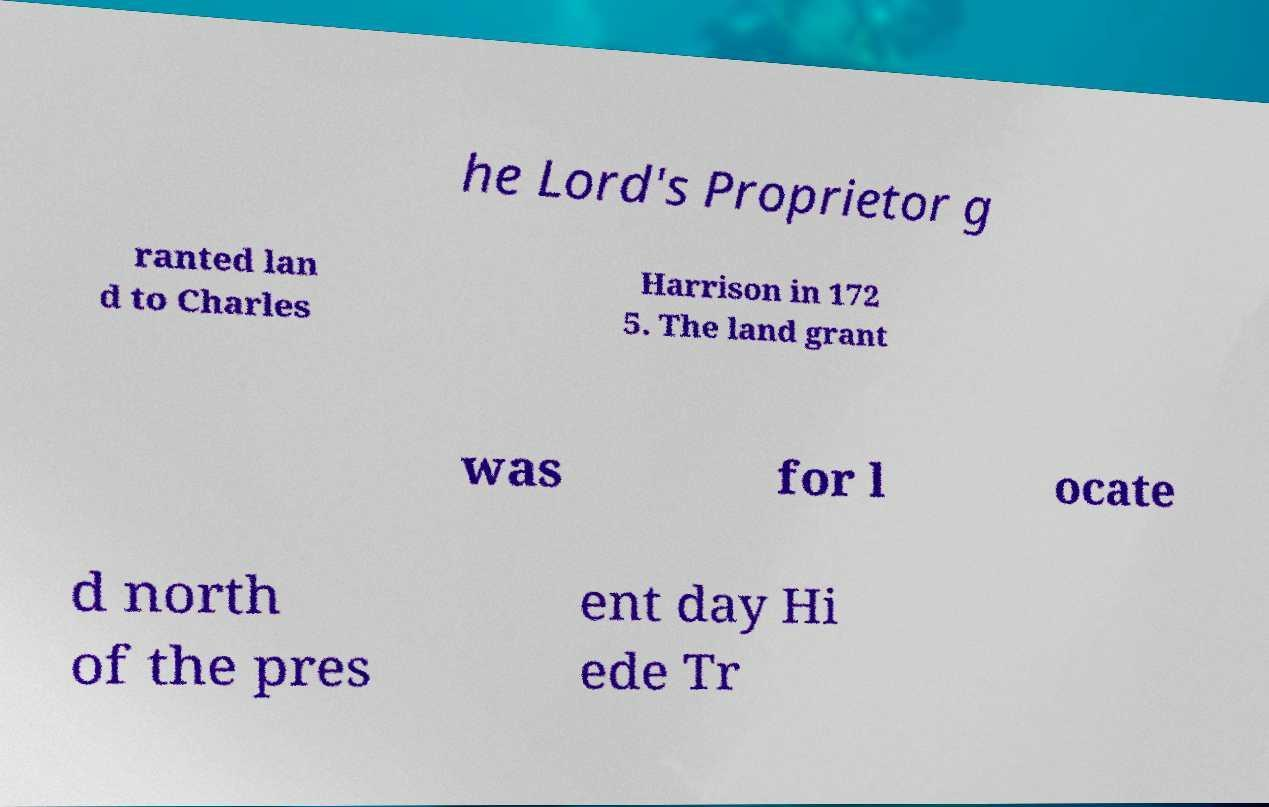Could you assist in decoding the text presented in this image and type it out clearly? he Lord's Proprietor g ranted lan d to Charles Harrison in 172 5. The land grant was for l ocate d north of the pres ent day Hi ede Tr 